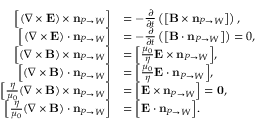Convert formula to latex. <formula><loc_0><loc_0><loc_500><loc_500>\begin{array} { r l } { { \left [ } ( \nabla \times { \mathbf E } ) \times n _ { P \rightarrow W } { \right ] } } & { = - \frac { \partial } { \partial t } \left ( { \left [ } { \mathbf B } \times n _ { P \rightarrow W } { \right ] } \right ) , } \\ { { \left [ } ( \nabla \times { \mathbf E } ) \cdot n _ { P \rightarrow W } { \right ] } } & { = - \frac { \partial } { \partial t } \left ( { \left [ } { \mathbf B } \cdot n _ { P \rightarrow W } { \right ] } \right ) = { 0 } , } \\ { { \left [ } ( \nabla \times { \mathbf B } ) \times n _ { P \rightarrow W } { \right ] } } & { = { \left [ } \frac { \mu _ { 0 } } { \eta } { \mathbf E } \times n _ { P \rightarrow W } { \right ] } , } \\ { { \left [ } ( \nabla \times { \mathbf B } ) \cdot n _ { P \rightarrow W } { \right ] } } & { = { \left [ } \frac { \mu _ { 0 } } { \eta } { \mathbf E } \cdot n _ { P \rightarrow W } { \right ] } , } \\ { { \left [ } \frac { \eta } { \mu _ { 0 } } ( \nabla \times { \mathbf B } ) \times n _ { P \rightarrow W } { \right ] } } & { = { \left [ } { \mathbf E } \times n _ { P \rightarrow W } { \right ] } = 0 , } \\ { { \left [ } \frac { \eta } { \mu _ { 0 } } ( \nabla \times { \mathbf B } ) \cdot n _ { P \rightarrow W } { \right ] } } & { = { \left [ } { \mathbf E } \cdot n _ { P \rightarrow W } { \right ] } . } \end{array}</formula> 